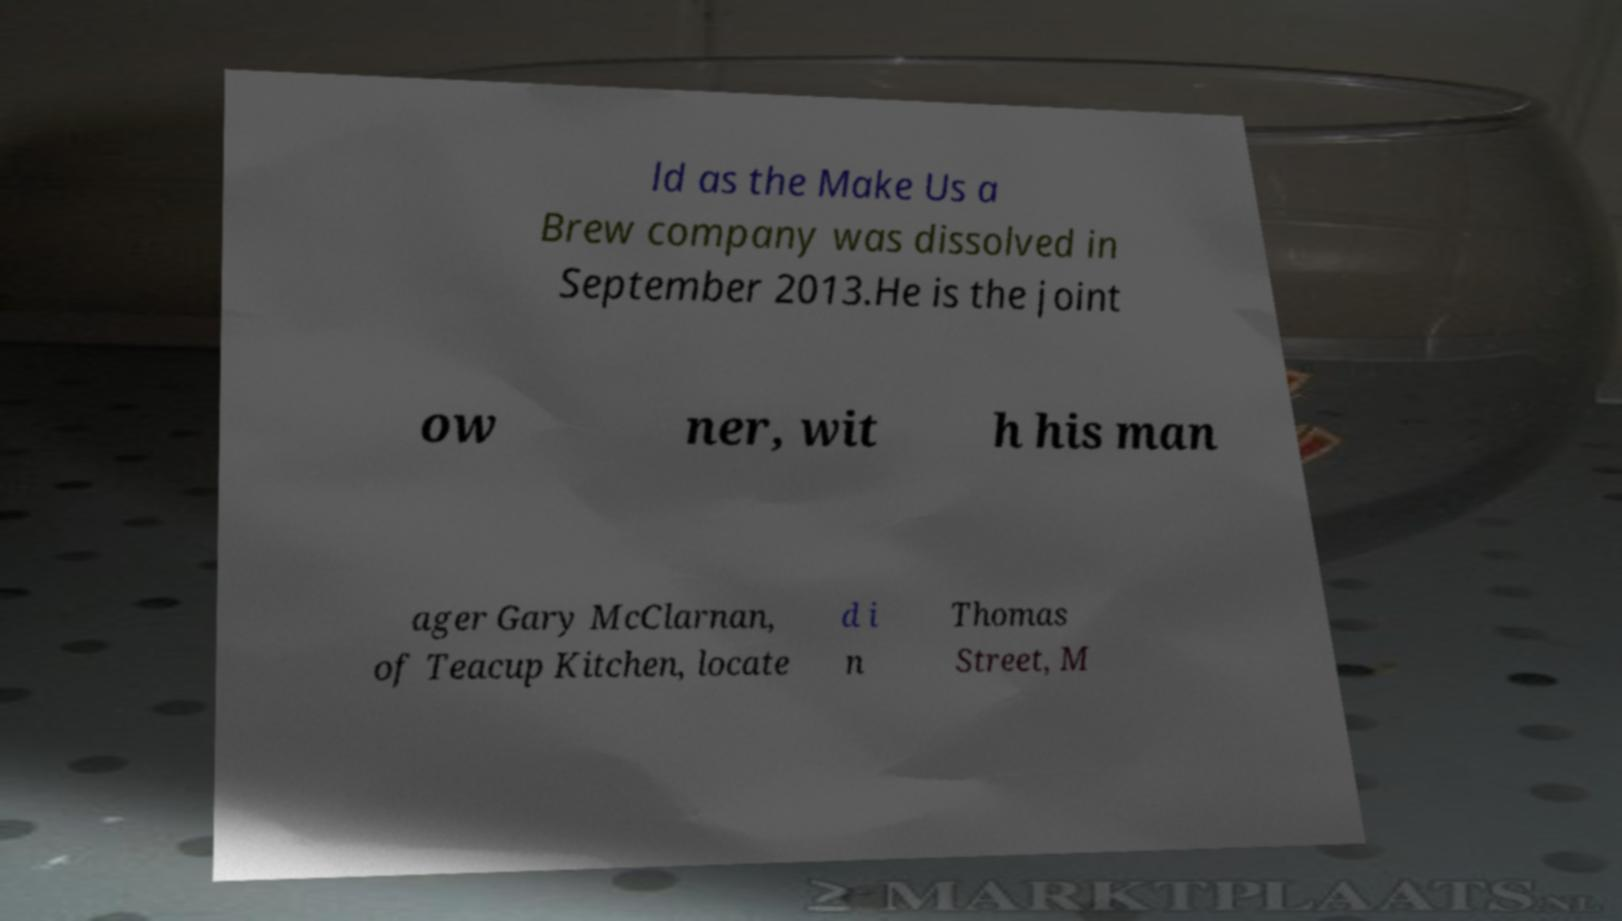For documentation purposes, I need the text within this image transcribed. Could you provide that? ld as the Make Us a Brew company was dissolved in September 2013.He is the joint ow ner, wit h his man ager Gary McClarnan, of Teacup Kitchen, locate d i n Thomas Street, M 